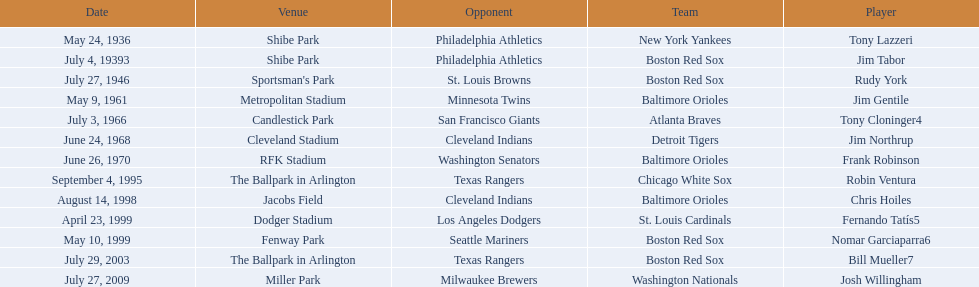Which teams faced off at miller park? Washington Nationals, Milwaukee Brewers. 